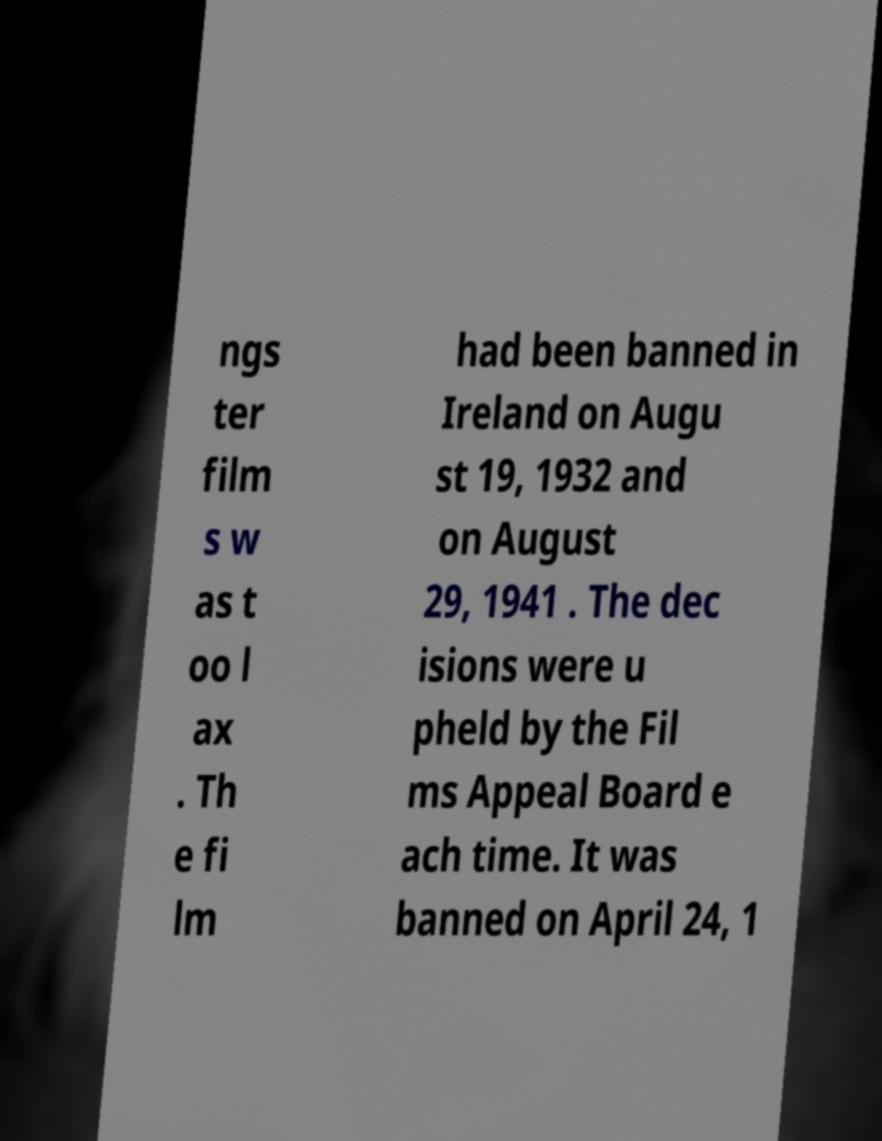Could you extract and type out the text from this image? ngs ter film s w as t oo l ax . Th e fi lm had been banned in Ireland on Augu st 19, 1932 and on August 29, 1941 . The dec isions were u pheld by the Fil ms Appeal Board e ach time. It was banned on April 24, 1 